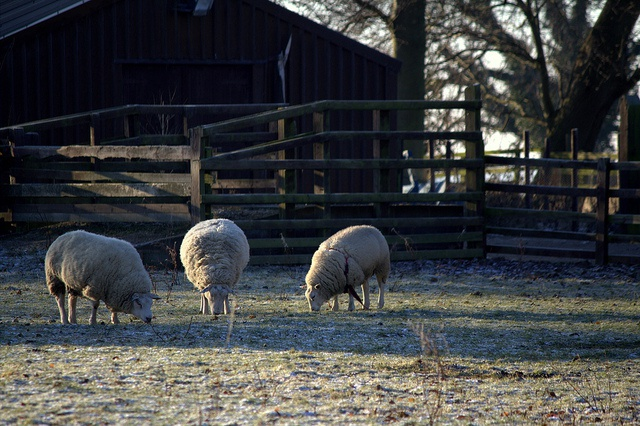Describe the objects in this image and their specific colors. I can see sheep in black, gray, and darkblue tones, sheep in black, gray, and darkblue tones, and sheep in black, gray, and darkblue tones in this image. 